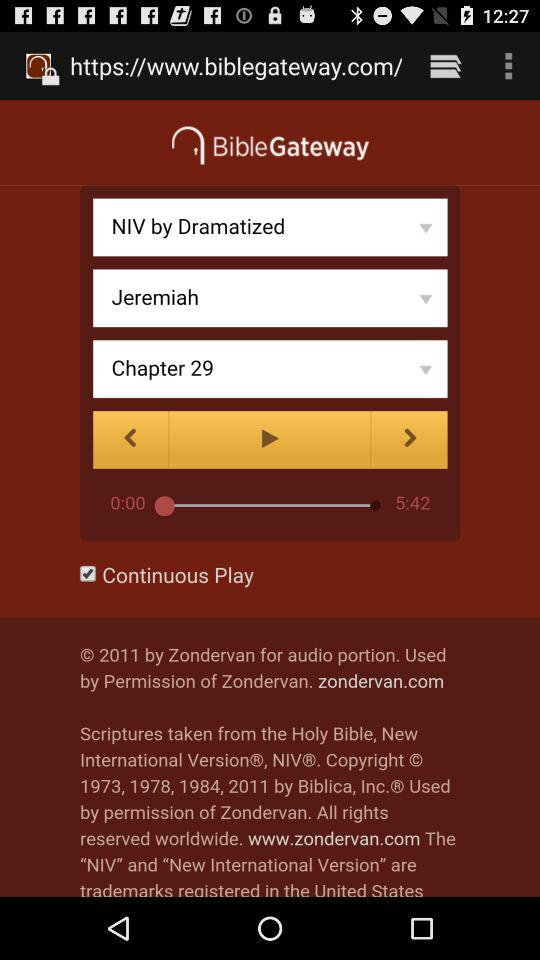What is the name of the application? The name of the application is "BibleGateway". 